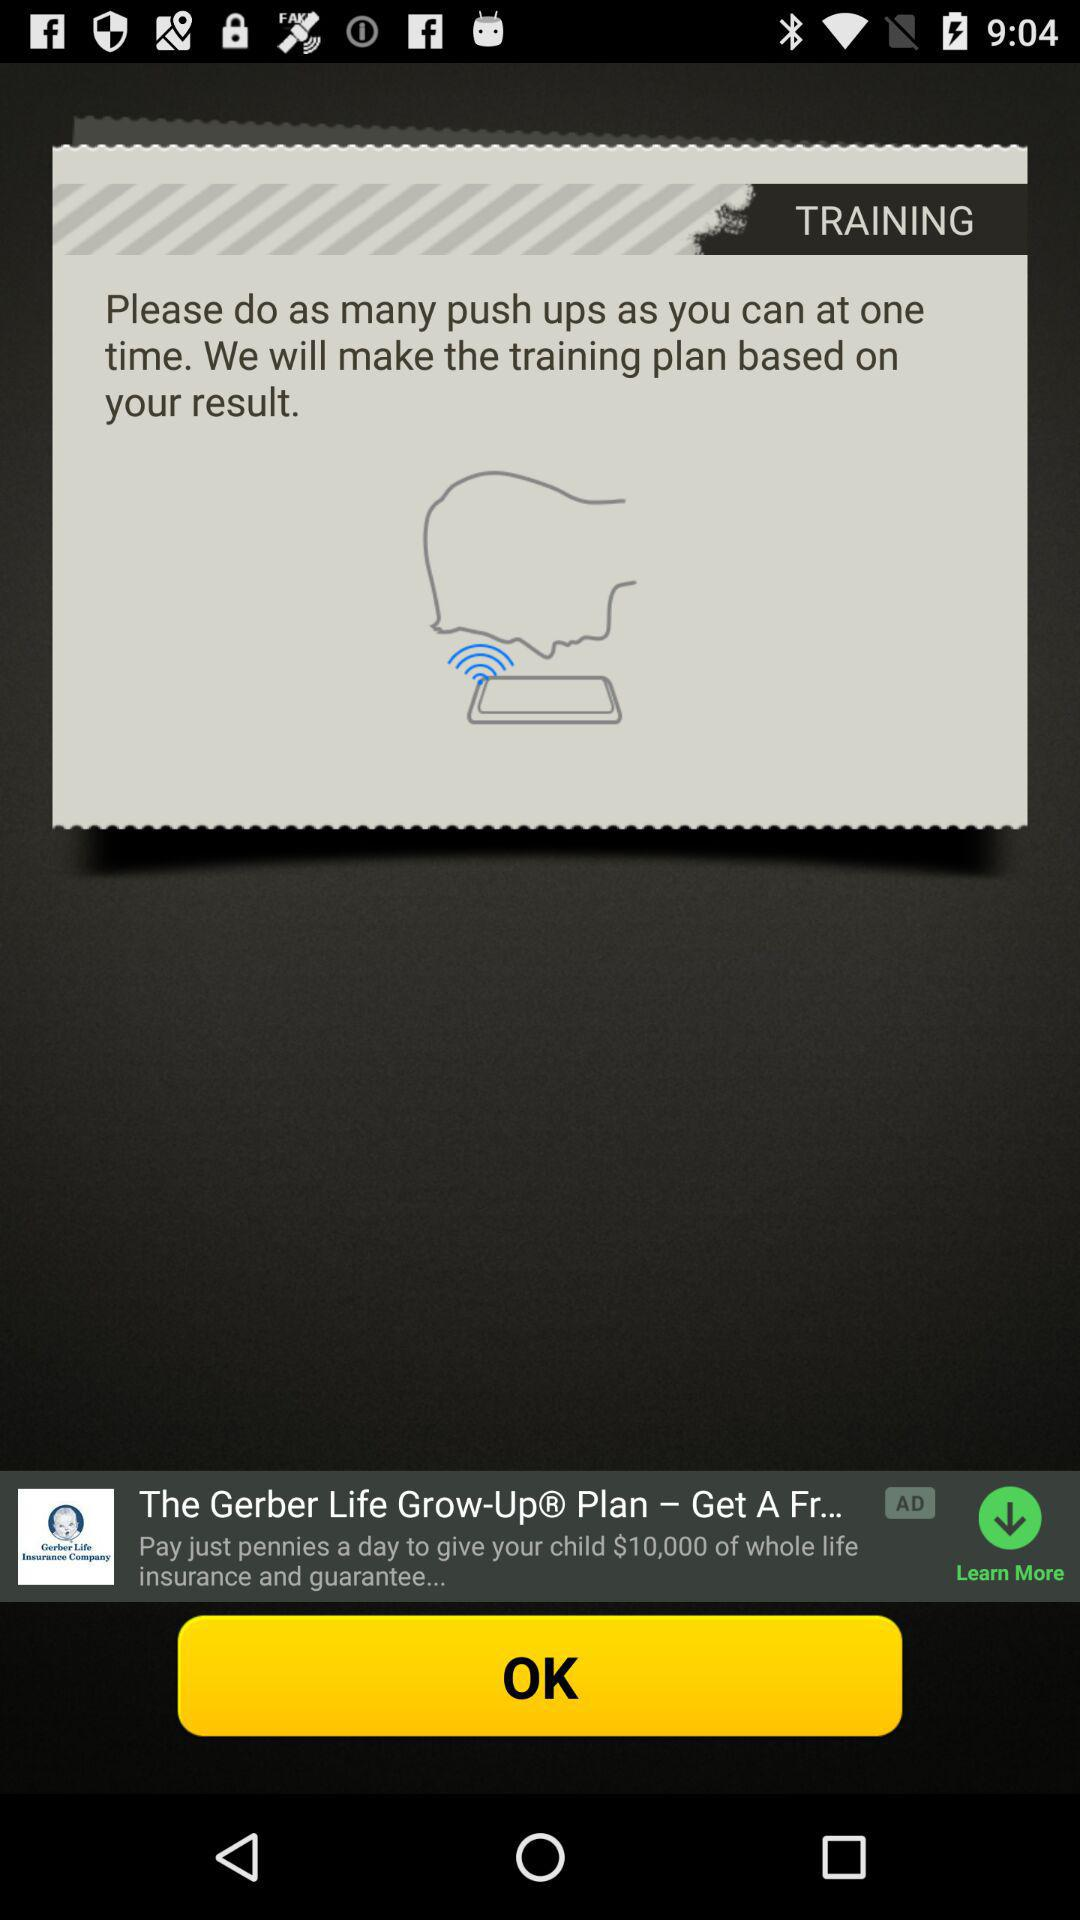When did the user begin the training plan?
When the provided information is insufficient, respond with <no answer>. <no answer> 